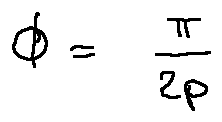Convert formula to latex. <formula><loc_0><loc_0><loc_500><loc_500>\phi = \frac { \pi } { 2 p }</formula> 